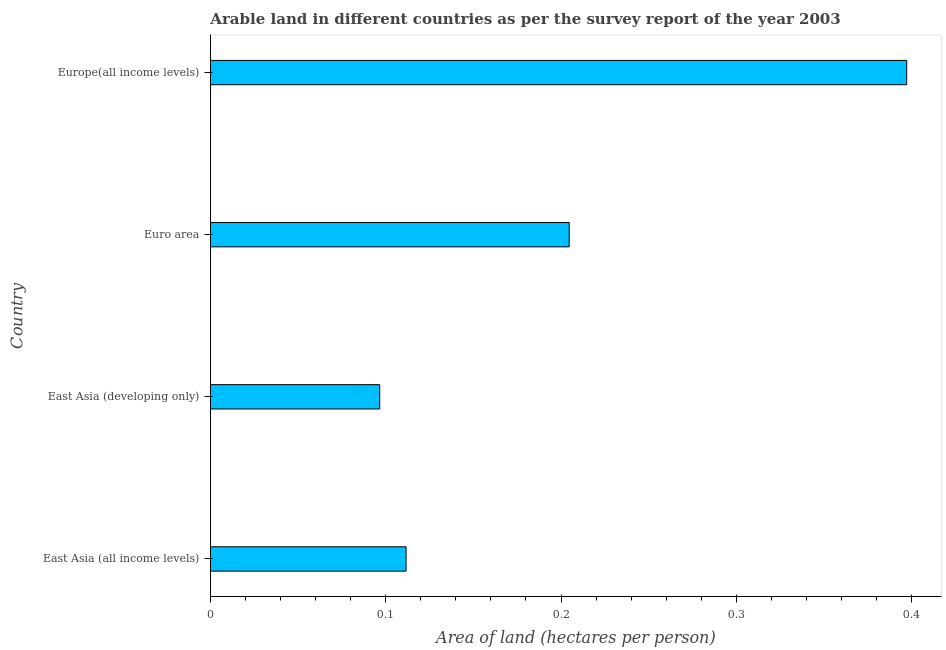What is the title of the graph?
Your answer should be compact. Arable land in different countries as per the survey report of the year 2003. What is the label or title of the X-axis?
Keep it short and to the point. Area of land (hectares per person). What is the label or title of the Y-axis?
Provide a short and direct response. Country. What is the area of arable land in Europe(all income levels)?
Offer a very short reply. 0.4. Across all countries, what is the maximum area of arable land?
Give a very brief answer. 0.4. Across all countries, what is the minimum area of arable land?
Offer a terse response. 0.1. In which country was the area of arable land maximum?
Ensure brevity in your answer.  Europe(all income levels). In which country was the area of arable land minimum?
Provide a short and direct response. East Asia (developing only). What is the sum of the area of arable land?
Keep it short and to the point. 0.81. What is the difference between the area of arable land in East Asia (all income levels) and Euro area?
Keep it short and to the point. -0.09. What is the average area of arable land per country?
Keep it short and to the point. 0.2. What is the median area of arable land?
Your answer should be very brief. 0.16. What is the ratio of the area of arable land in Euro area to that in Europe(all income levels)?
Provide a short and direct response. 0.52. What is the difference between the highest and the second highest area of arable land?
Make the answer very short. 0.19. In how many countries, is the area of arable land greater than the average area of arable land taken over all countries?
Your answer should be very brief. 2. How many bars are there?
Make the answer very short. 4. What is the Area of land (hectares per person) of East Asia (all income levels)?
Your response must be concise. 0.11. What is the Area of land (hectares per person) in East Asia (developing only)?
Your response must be concise. 0.1. What is the Area of land (hectares per person) of Euro area?
Give a very brief answer. 0.2. What is the Area of land (hectares per person) of Europe(all income levels)?
Offer a very short reply. 0.4. What is the difference between the Area of land (hectares per person) in East Asia (all income levels) and East Asia (developing only)?
Your answer should be very brief. 0.02. What is the difference between the Area of land (hectares per person) in East Asia (all income levels) and Euro area?
Your response must be concise. -0.09. What is the difference between the Area of land (hectares per person) in East Asia (all income levels) and Europe(all income levels)?
Make the answer very short. -0.29. What is the difference between the Area of land (hectares per person) in East Asia (developing only) and Euro area?
Your response must be concise. -0.11. What is the difference between the Area of land (hectares per person) in East Asia (developing only) and Europe(all income levels)?
Make the answer very short. -0.3. What is the difference between the Area of land (hectares per person) in Euro area and Europe(all income levels)?
Offer a terse response. -0.19. What is the ratio of the Area of land (hectares per person) in East Asia (all income levels) to that in East Asia (developing only)?
Give a very brief answer. 1.16. What is the ratio of the Area of land (hectares per person) in East Asia (all income levels) to that in Euro area?
Your answer should be compact. 0.55. What is the ratio of the Area of land (hectares per person) in East Asia (all income levels) to that in Europe(all income levels)?
Offer a terse response. 0.28. What is the ratio of the Area of land (hectares per person) in East Asia (developing only) to that in Euro area?
Give a very brief answer. 0.47. What is the ratio of the Area of land (hectares per person) in East Asia (developing only) to that in Europe(all income levels)?
Offer a very short reply. 0.24. What is the ratio of the Area of land (hectares per person) in Euro area to that in Europe(all income levels)?
Give a very brief answer. 0.52. 